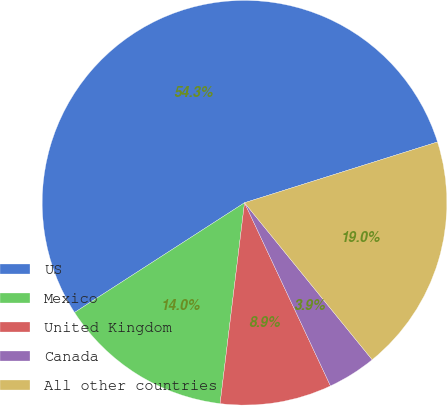<chart> <loc_0><loc_0><loc_500><loc_500><pie_chart><fcel>US<fcel>Mexico<fcel>United Kingdom<fcel>Canada<fcel>All other countries<nl><fcel>54.26%<fcel>13.95%<fcel>8.91%<fcel>3.88%<fcel>18.99%<nl></chart> 